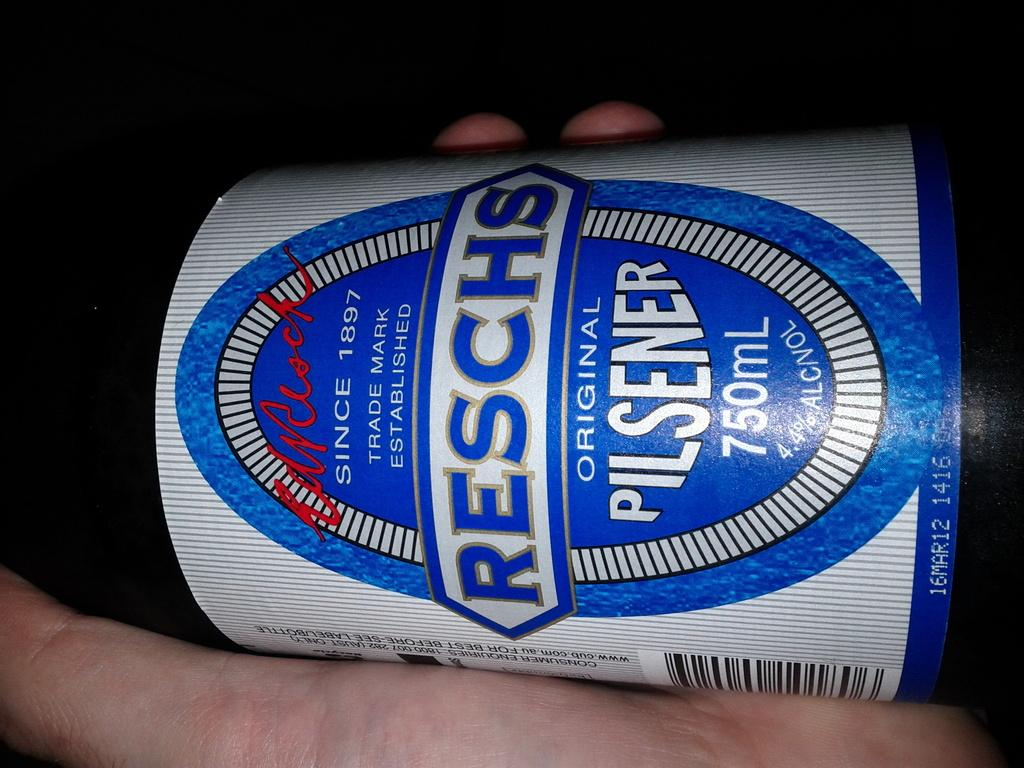<image>
Give a short and clear explanation of the subsequent image. the word reschs that is on a blue can 